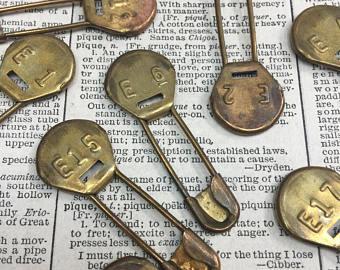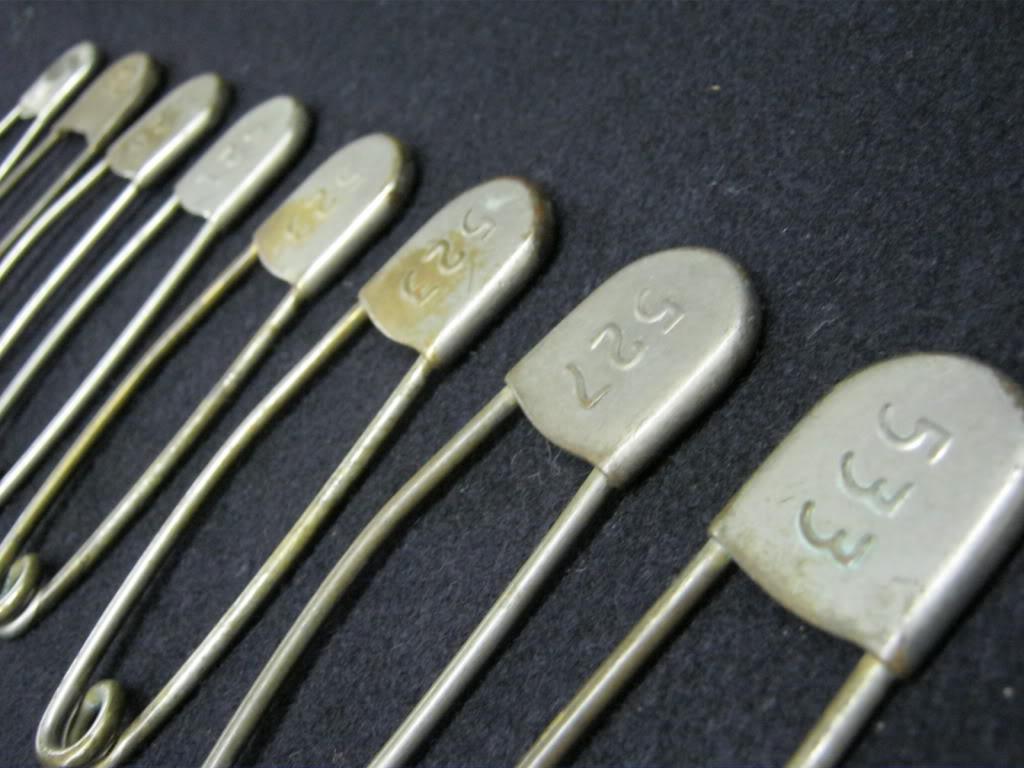The first image is the image on the left, the second image is the image on the right. For the images shown, is this caption "Some safety pins have letters and numbers on them." true? Answer yes or no. Yes. The first image is the image on the left, the second image is the image on the right. Analyze the images presented: Is the assertion "there is at least one ribbon tied in a bow with bobby pins on a wooden surface" valid? Answer yes or no. No. 